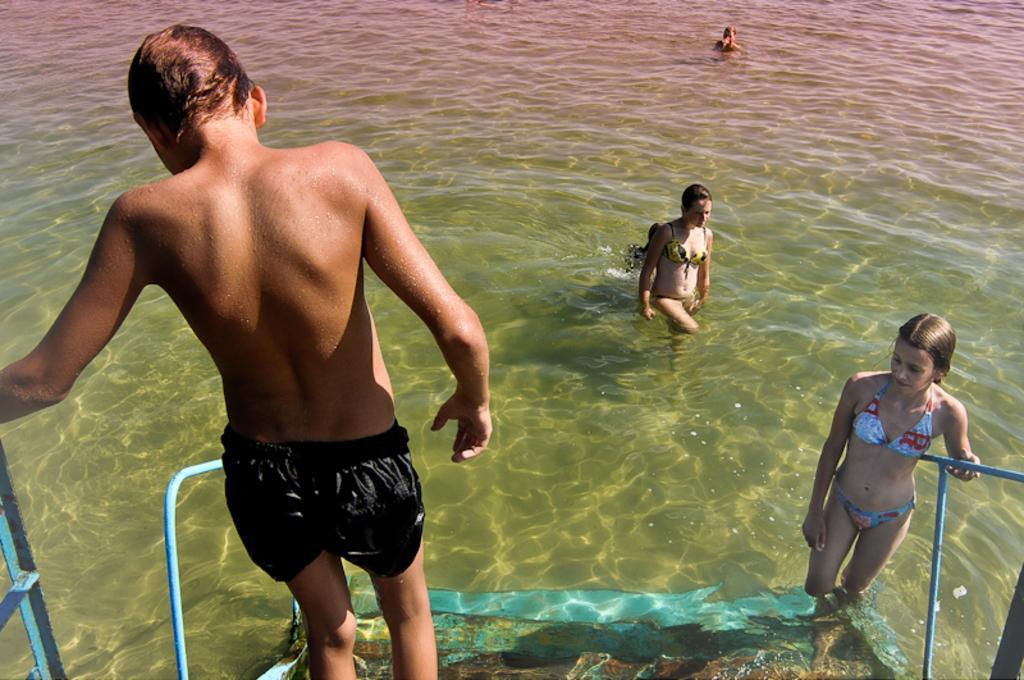Describe this image in one or two sentences. In this image we can see some persons wearing shorts and bikinis swimming in the water, at the foreground of the image there are two persons who are walking on the stairs. 